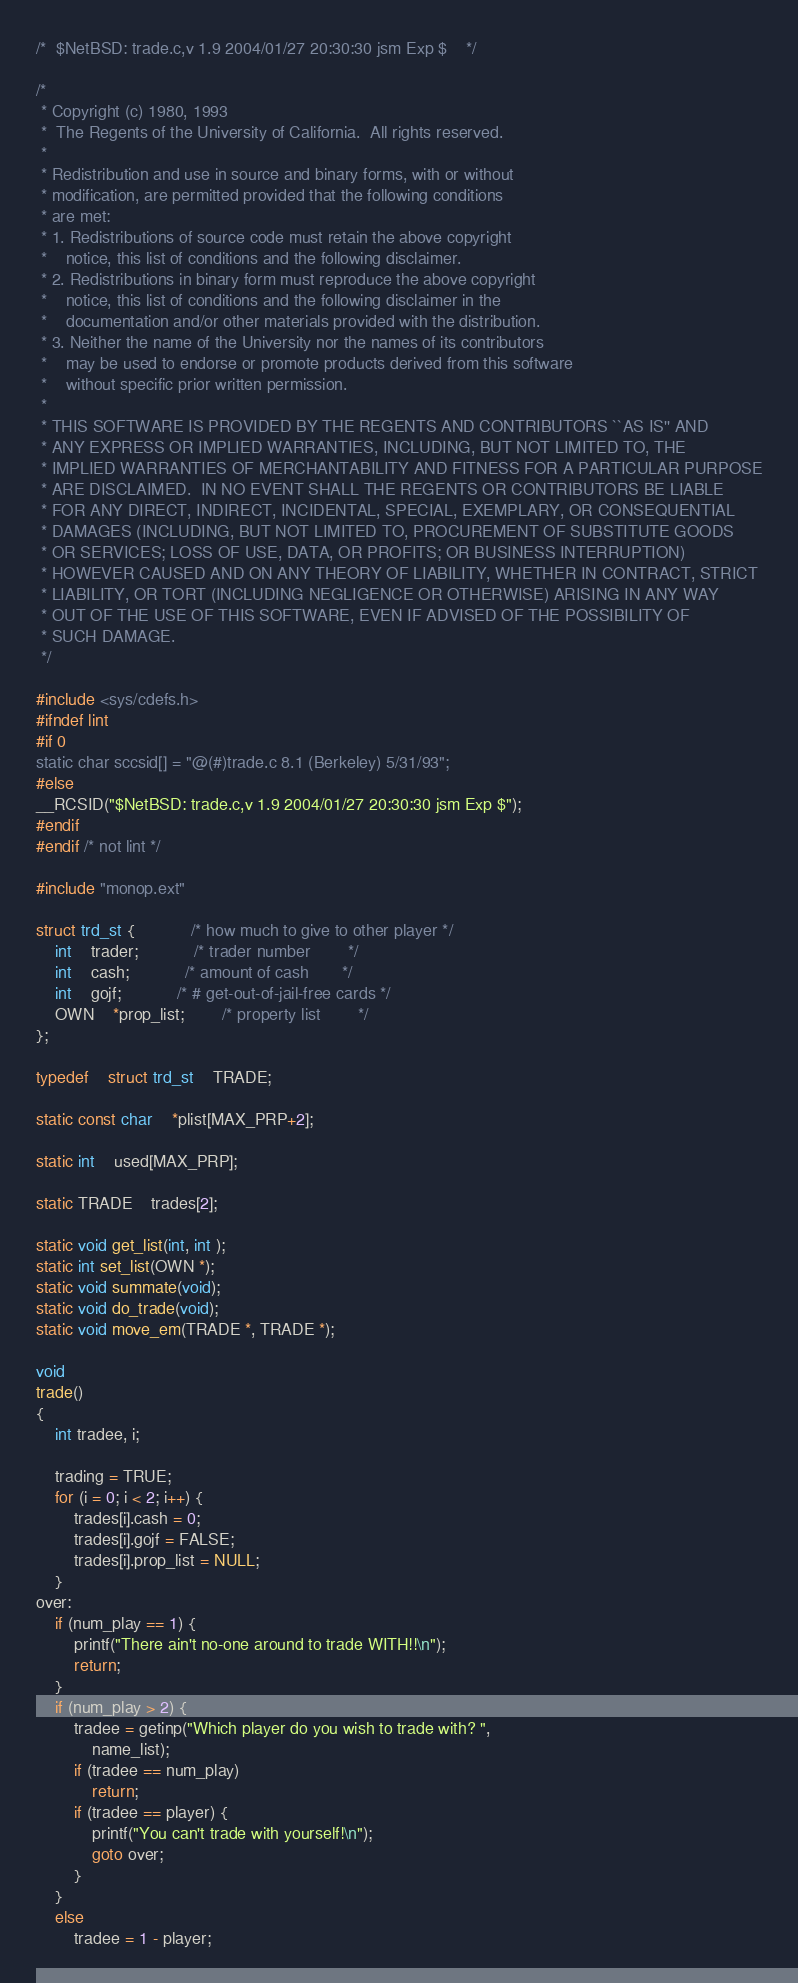<code> <loc_0><loc_0><loc_500><loc_500><_C_>/*	$NetBSD: trade.c,v 1.9 2004/01/27 20:30:30 jsm Exp $	*/

/*
 * Copyright (c) 1980, 1993
 *	The Regents of the University of California.  All rights reserved.
 *
 * Redistribution and use in source and binary forms, with or without
 * modification, are permitted provided that the following conditions
 * are met:
 * 1. Redistributions of source code must retain the above copyright
 *    notice, this list of conditions and the following disclaimer.
 * 2. Redistributions in binary form must reproduce the above copyright
 *    notice, this list of conditions and the following disclaimer in the
 *    documentation and/or other materials provided with the distribution.
 * 3. Neither the name of the University nor the names of its contributors
 *    may be used to endorse or promote products derived from this software
 *    without specific prior written permission.
 *
 * THIS SOFTWARE IS PROVIDED BY THE REGENTS AND CONTRIBUTORS ``AS IS'' AND
 * ANY EXPRESS OR IMPLIED WARRANTIES, INCLUDING, BUT NOT LIMITED TO, THE
 * IMPLIED WARRANTIES OF MERCHANTABILITY AND FITNESS FOR A PARTICULAR PURPOSE
 * ARE DISCLAIMED.  IN NO EVENT SHALL THE REGENTS OR CONTRIBUTORS BE LIABLE
 * FOR ANY DIRECT, INDIRECT, INCIDENTAL, SPECIAL, EXEMPLARY, OR CONSEQUENTIAL
 * DAMAGES (INCLUDING, BUT NOT LIMITED TO, PROCUREMENT OF SUBSTITUTE GOODS
 * OR SERVICES; LOSS OF USE, DATA, OR PROFITS; OR BUSINESS INTERRUPTION)
 * HOWEVER CAUSED AND ON ANY THEORY OF LIABILITY, WHETHER IN CONTRACT, STRICT
 * LIABILITY, OR TORT (INCLUDING NEGLIGENCE OR OTHERWISE) ARISING IN ANY WAY
 * OUT OF THE USE OF THIS SOFTWARE, EVEN IF ADVISED OF THE POSSIBILITY OF
 * SUCH DAMAGE.
 */

#include <sys/cdefs.h>
#ifndef lint
#if 0
static char sccsid[] = "@(#)trade.c	8.1 (Berkeley) 5/31/93";
#else
__RCSID("$NetBSD: trade.c,v 1.9 2004/01/27 20:30:30 jsm Exp $");
#endif
#endif /* not lint */

#include "monop.ext"

struct trd_st {			/* how much to give to other player	*/
	int	trader;			/* trader number		*/
	int	cash;			/* amount of cash 		*/
	int	gojf;			/* # get-out-of-jail-free cards	*/
	OWN	*prop_list;		/* property list		*/
};

typedef	struct trd_st	TRADE;

static const char	*plist[MAX_PRP+2];

static int	used[MAX_PRP];

static TRADE	trades[2];

static void get_list(int, int );
static int set_list(OWN *);
static void summate(void);
static void do_trade(void);
static void move_em(TRADE *, TRADE *);

void
trade()
{
	int tradee, i;

	trading = TRUE;
	for (i = 0; i < 2; i++) {
		trades[i].cash = 0;
		trades[i].gojf = FALSE;
		trades[i].prop_list = NULL;
	}
over:
	if (num_play == 1) {
		printf("There ain't no-one around to trade WITH!!\n");
		return;
	}
	if (num_play > 2) {
		tradee = getinp("Which player do you wish to trade with? ",
		    name_list);
		if (tradee == num_play)
			return;
		if (tradee == player) {
			printf("You can't trade with yourself!\n");
			goto over;
		}
	}
	else
		tradee = 1 - player;</code> 